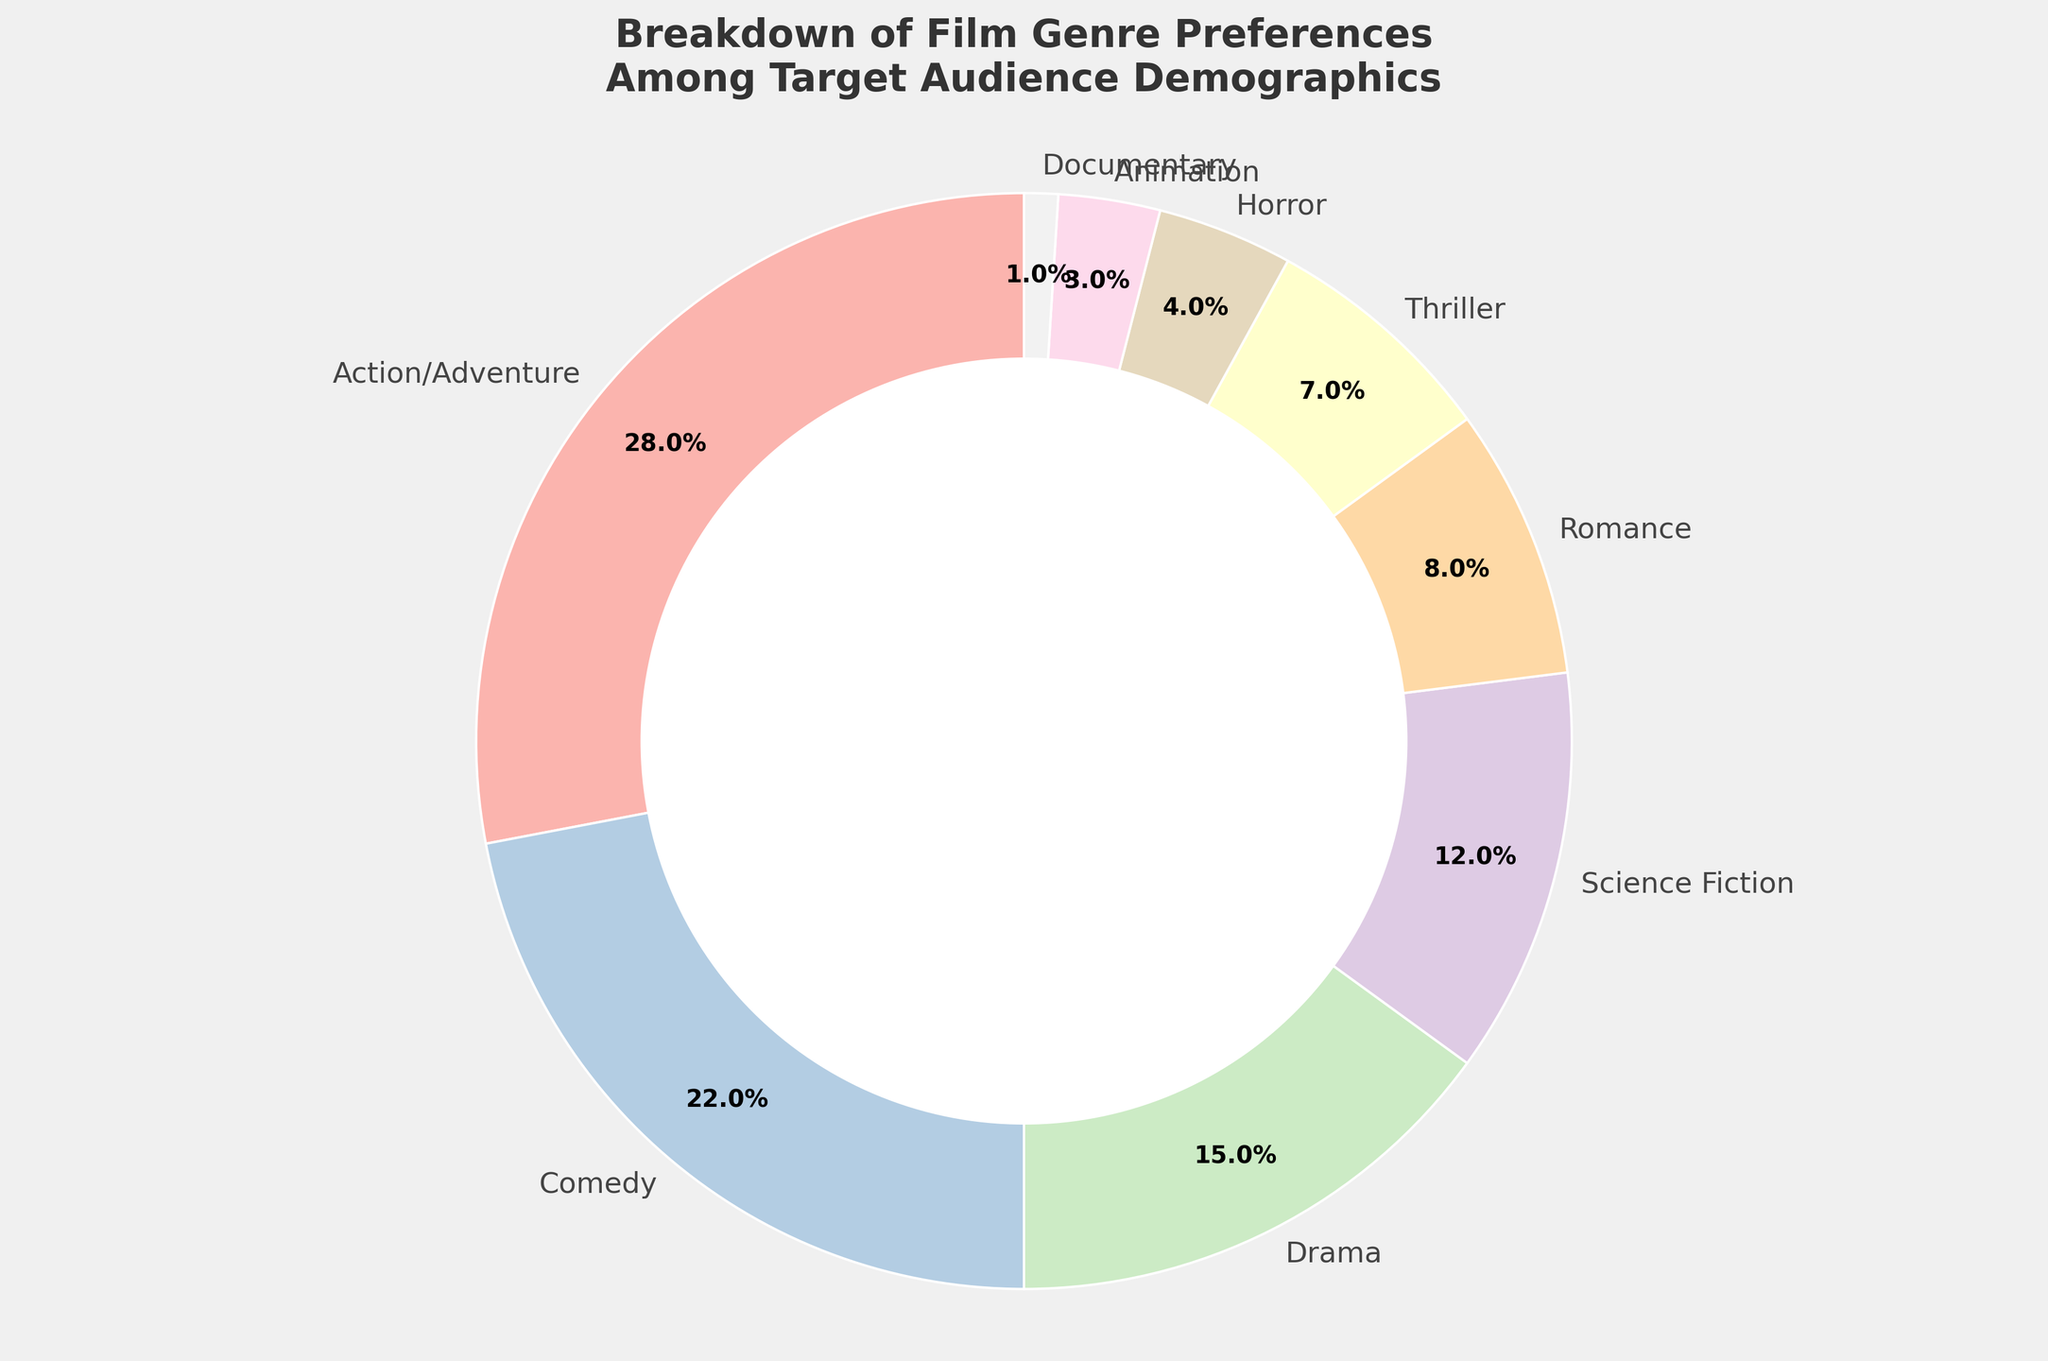Which genre has the highest percentage of preference among the target audience? The genre with the highest percentage is represented by the largest wedge in the pie chart. From the chart, Action/Adventure is the largest segment.
Answer: Action/Adventure Which genre has the smallest percentage of preference among the target audience? The genre with the smallest percentage is represented by the smallest wedge in the pie chart. From the chart, Documentary is the smallest segment.
Answer: Documentary What is the combined percentage preference for Action/Adventure and Comedy genres? To find the combined preference, sum the percentages of Action/Adventure and Comedy. Action/Adventure is 28%, and Comedy is 22%. So, 28% + 22% = 50%.
Answer: 50% How does the preference for Science Fiction compare to that of Horror? Compare the percentages of Science Fiction and Horror. Science Fiction is 12%, while Horror is 4%. Since 12% > 4%, Science Fiction has a higher preference.
Answer: Science Fiction has a higher preference What is the total percentage for genres with less than 10% preference each? Identify the genres with percentages less than 10% and sum them up. Those are Romance (8%), Thriller (7%), Horror (4%), Animation (3%), and Documentary (1%). So, 8% + 7% + 4% + 3% + 1% = 23%.
Answer: 23% Which genres together make up over 50% of the audience preferences? Determine which genres add up to more than 50% by summing the largest percentages until the total exceeds 50%. Action/Adventure (28%) + Comedy (22%) = 50%. Since 50% exactly hits the threshold, no need to include more genres.
Answer: Action/Adventure and Comedy Are the combined percentages of Animation and Documentary larger than Thriller? Sum the percentages of Animation and Documentary, then compare to Thriller. Animation is 3%, and Documentary is 1%, so their combined percentage is 3% + 1% = 4%. Thriller is 7%, which is greater than 4%.
Answer: No, they are not larger What is the difference in percentage preference between Drama and Romance? Subtract the percentage of Romance from Drama. Drama is 15%, and Romance is 8%. So, 15% - 8% = 7%.
Answer: 7% Which genre has the second lowest preference among the audience? The second smallest wedge in the pie chart represents the second lowest preference. After Documentary (1%), the next smallest segment is Animation (3%).
Answer: Animation 